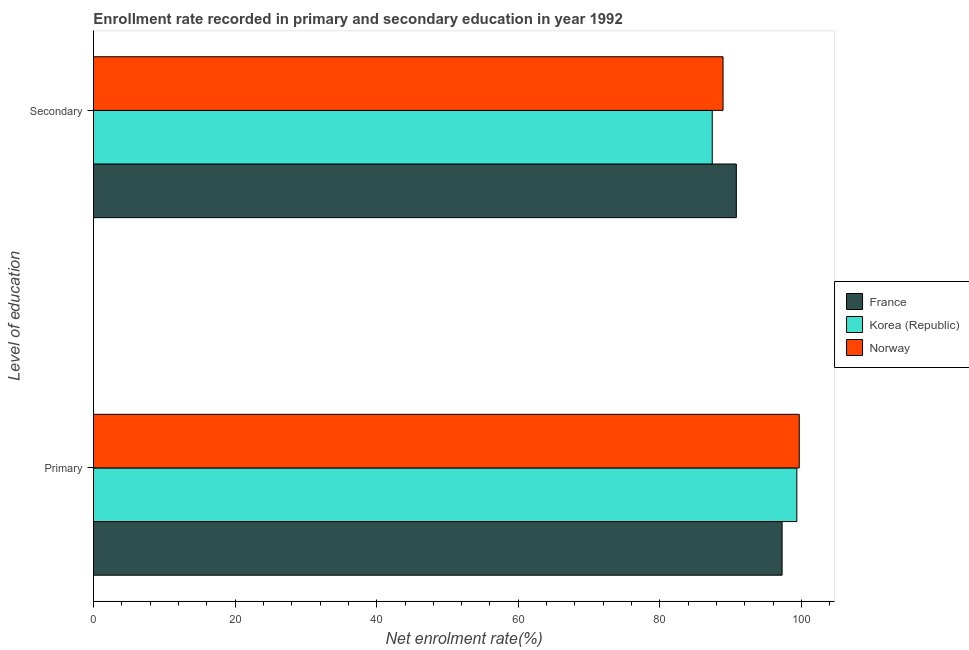How many different coloured bars are there?
Offer a terse response. 3. How many groups of bars are there?
Keep it short and to the point. 2. How many bars are there on the 1st tick from the top?
Offer a terse response. 3. How many bars are there on the 2nd tick from the bottom?
Provide a succinct answer. 3. What is the label of the 1st group of bars from the top?
Offer a very short reply. Secondary. What is the enrollment rate in primary education in Korea (Republic)?
Keep it short and to the point. 99.34. Across all countries, what is the maximum enrollment rate in primary education?
Make the answer very short. 99.68. Across all countries, what is the minimum enrollment rate in secondary education?
Make the answer very short. 87.39. In which country was the enrollment rate in secondary education maximum?
Ensure brevity in your answer.  France. In which country was the enrollment rate in primary education minimum?
Offer a very short reply. France. What is the total enrollment rate in secondary education in the graph?
Your answer should be compact. 267.09. What is the difference between the enrollment rate in secondary education in France and that in Korea (Republic)?
Your answer should be compact. 3.4. What is the difference between the enrollment rate in secondary education in Norway and the enrollment rate in primary education in Korea (Republic)?
Give a very brief answer. -10.42. What is the average enrollment rate in primary education per country?
Keep it short and to the point. 98.76. What is the difference between the enrollment rate in secondary education and enrollment rate in primary education in Korea (Republic)?
Ensure brevity in your answer.  -11.95. In how many countries, is the enrollment rate in secondary education greater than 16 %?
Provide a succinct answer. 3. What is the ratio of the enrollment rate in secondary education in France to that in Norway?
Offer a very short reply. 1.02. Is the enrollment rate in primary education in Norway less than that in France?
Provide a short and direct response. No. What does the 3rd bar from the bottom in Secondary represents?
Provide a short and direct response. Norway. How many bars are there?
Your response must be concise. 6. How many countries are there in the graph?
Keep it short and to the point. 3. What is the difference between two consecutive major ticks on the X-axis?
Offer a very short reply. 20. Does the graph contain grids?
Provide a succinct answer. No. Where does the legend appear in the graph?
Your answer should be compact. Center right. How are the legend labels stacked?
Provide a short and direct response. Vertical. What is the title of the graph?
Offer a terse response. Enrollment rate recorded in primary and secondary education in year 1992. What is the label or title of the X-axis?
Your answer should be compact. Net enrolment rate(%). What is the label or title of the Y-axis?
Your response must be concise. Level of education. What is the Net enrolment rate(%) of France in Primary?
Give a very brief answer. 97.25. What is the Net enrolment rate(%) of Korea (Republic) in Primary?
Your answer should be compact. 99.34. What is the Net enrolment rate(%) in Norway in Primary?
Provide a succinct answer. 99.68. What is the Net enrolment rate(%) in France in Secondary?
Provide a short and direct response. 90.79. What is the Net enrolment rate(%) in Korea (Republic) in Secondary?
Keep it short and to the point. 87.39. What is the Net enrolment rate(%) in Norway in Secondary?
Ensure brevity in your answer.  88.91. Across all Level of education, what is the maximum Net enrolment rate(%) in France?
Offer a very short reply. 97.25. Across all Level of education, what is the maximum Net enrolment rate(%) of Korea (Republic)?
Your response must be concise. 99.34. Across all Level of education, what is the maximum Net enrolment rate(%) in Norway?
Give a very brief answer. 99.68. Across all Level of education, what is the minimum Net enrolment rate(%) in France?
Provide a short and direct response. 90.79. Across all Level of education, what is the minimum Net enrolment rate(%) in Korea (Republic)?
Provide a short and direct response. 87.39. Across all Level of education, what is the minimum Net enrolment rate(%) of Norway?
Your response must be concise. 88.91. What is the total Net enrolment rate(%) in France in the graph?
Your answer should be compact. 188.04. What is the total Net enrolment rate(%) in Korea (Republic) in the graph?
Offer a terse response. 186.73. What is the total Net enrolment rate(%) of Norway in the graph?
Your answer should be compact. 188.59. What is the difference between the Net enrolment rate(%) of France in Primary and that in Secondary?
Give a very brief answer. 6.47. What is the difference between the Net enrolment rate(%) of Korea (Republic) in Primary and that in Secondary?
Give a very brief answer. 11.95. What is the difference between the Net enrolment rate(%) of Norway in Primary and that in Secondary?
Ensure brevity in your answer.  10.76. What is the difference between the Net enrolment rate(%) in France in Primary and the Net enrolment rate(%) in Korea (Republic) in Secondary?
Offer a very short reply. 9.86. What is the difference between the Net enrolment rate(%) in France in Primary and the Net enrolment rate(%) in Norway in Secondary?
Provide a succinct answer. 8.34. What is the difference between the Net enrolment rate(%) in Korea (Republic) in Primary and the Net enrolment rate(%) in Norway in Secondary?
Provide a succinct answer. 10.42. What is the average Net enrolment rate(%) of France per Level of education?
Make the answer very short. 94.02. What is the average Net enrolment rate(%) of Korea (Republic) per Level of education?
Offer a terse response. 93.36. What is the average Net enrolment rate(%) in Norway per Level of education?
Your answer should be compact. 94.3. What is the difference between the Net enrolment rate(%) in France and Net enrolment rate(%) in Korea (Republic) in Primary?
Your answer should be compact. -2.08. What is the difference between the Net enrolment rate(%) in France and Net enrolment rate(%) in Norway in Primary?
Ensure brevity in your answer.  -2.42. What is the difference between the Net enrolment rate(%) of Korea (Republic) and Net enrolment rate(%) of Norway in Primary?
Your response must be concise. -0.34. What is the difference between the Net enrolment rate(%) in France and Net enrolment rate(%) in Korea (Republic) in Secondary?
Your response must be concise. 3.4. What is the difference between the Net enrolment rate(%) in France and Net enrolment rate(%) in Norway in Secondary?
Your answer should be very brief. 1.87. What is the difference between the Net enrolment rate(%) of Korea (Republic) and Net enrolment rate(%) of Norway in Secondary?
Provide a short and direct response. -1.52. What is the ratio of the Net enrolment rate(%) of France in Primary to that in Secondary?
Ensure brevity in your answer.  1.07. What is the ratio of the Net enrolment rate(%) of Korea (Republic) in Primary to that in Secondary?
Your response must be concise. 1.14. What is the ratio of the Net enrolment rate(%) in Norway in Primary to that in Secondary?
Offer a very short reply. 1.12. What is the difference between the highest and the second highest Net enrolment rate(%) of France?
Your answer should be compact. 6.47. What is the difference between the highest and the second highest Net enrolment rate(%) in Korea (Republic)?
Keep it short and to the point. 11.95. What is the difference between the highest and the second highest Net enrolment rate(%) in Norway?
Your answer should be compact. 10.76. What is the difference between the highest and the lowest Net enrolment rate(%) in France?
Your response must be concise. 6.47. What is the difference between the highest and the lowest Net enrolment rate(%) of Korea (Republic)?
Give a very brief answer. 11.95. What is the difference between the highest and the lowest Net enrolment rate(%) of Norway?
Keep it short and to the point. 10.76. 